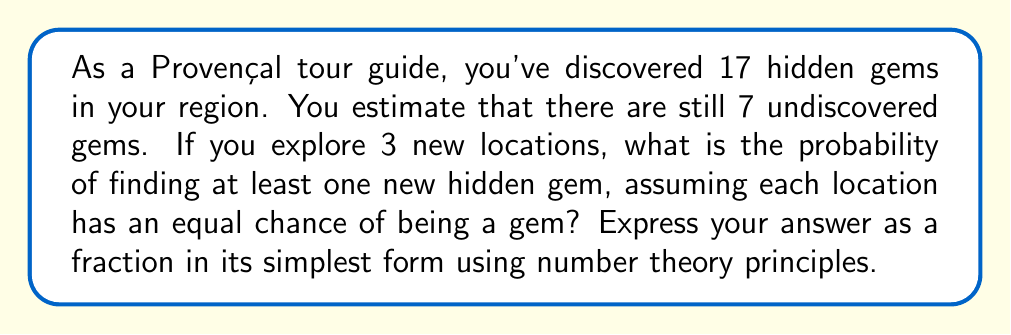Help me with this question. Let's approach this step-by-step using number theory and probability principles:

1) First, we need to calculate the total number of locations:
   Known gems + Undiscovered gems = $17 + 7 = 24$ total locations

2) The probability of a location being an undiscovered gem is:
   $P(\text{gem}) = \frac{7}{24}$

3) The probability of a location not being a gem is:
   $P(\text{not gem}) = 1 - \frac{7}{24} = \frac{17}{24}$

4) We want the probability of finding at least one gem in 3 attempts. It's easier to calculate the probability of not finding any gems and then subtract from 1:

   $P(\text{at least one gem}) = 1 - P(\text{no gems})$

5) The probability of not finding a gem in 3 attempts is:
   $P(\text{no gems}) = (\frac{17}{24})^3$

6) Therefore, the probability of finding at least one gem is:
   $P(\text{at least one gem}) = 1 - (\frac{17}{24})^3$

7) Let's calculate this:
   $1 - (\frac{17}{24})^3 = 1 - \frac{4913}{13824} = \frac{13824 - 4913}{13824} = \frac{8911}{13824}$

8) To simplify this fraction, we need to find the greatest common divisor (GCD) of 8911 and 13824.
   Using the Euclidean algorithm:
   $13824 = 1 \times 8911 + 4913$
   $8911 = 1 \times 4913 + 3998$
   $4913 = 1 \times 3998 + 915$
   $3998 = 4 \times 915 + 338$
   $915 = 2 \times 338 + 239$
   $338 = 1 \times 239 + 99$
   $239 = 2 \times 99 + 41$
   $99 = 2 \times 41 + 17$
   $41 = 2 \times 17 + 7$
   $17 = 2 \times 7 + 3$
   $7 = 2 \times 3 + 1$
   $3 = 3 \times 1 + 0$

   The GCD is 1, so the fraction is already in its simplest form.
Answer: $\frac{8911}{13824}$ 